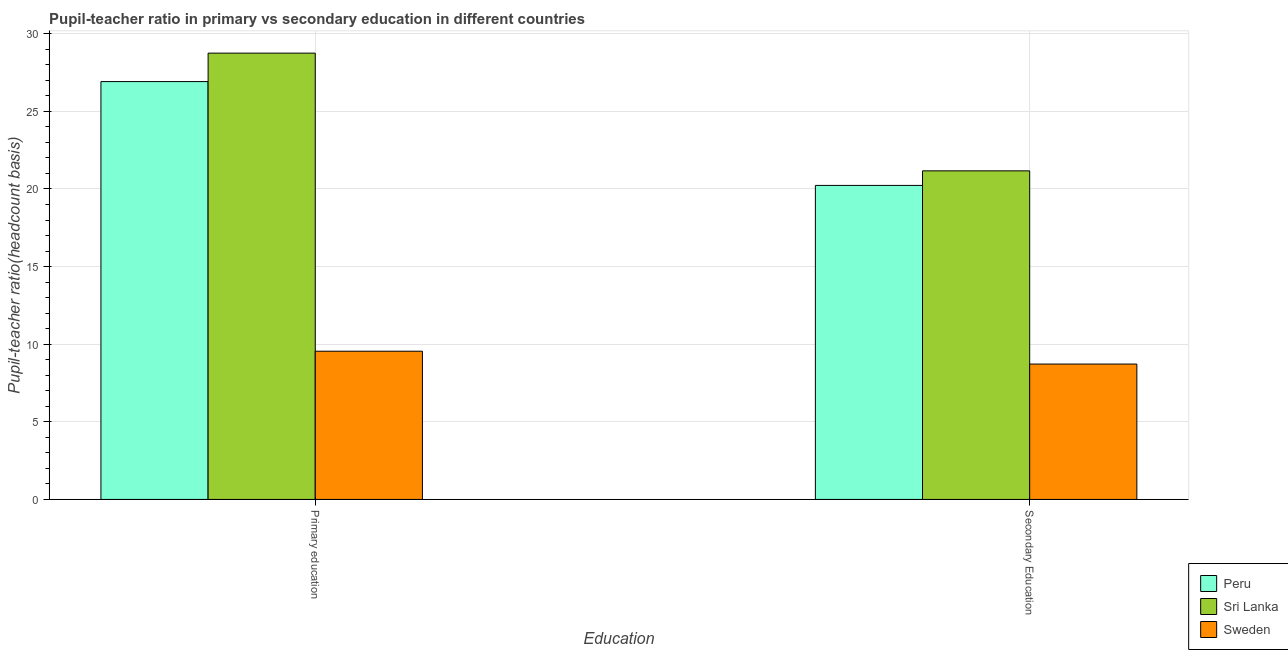How many different coloured bars are there?
Ensure brevity in your answer.  3. How many groups of bars are there?
Keep it short and to the point. 2. Are the number of bars on each tick of the X-axis equal?
Keep it short and to the point. Yes. How many bars are there on the 2nd tick from the left?
Ensure brevity in your answer.  3. How many bars are there on the 1st tick from the right?
Your response must be concise. 3. What is the label of the 1st group of bars from the left?
Make the answer very short. Primary education. What is the pupil teacher ratio on secondary education in Sweden?
Offer a terse response. 8.72. Across all countries, what is the maximum pupil teacher ratio on secondary education?
Your answer should be very brief. 21.17. Across all countries, what is the minimum pupil teacher ratio on secondary education?
Provide a short and direct response. 8.72. In which country was the pupil teacher ratio on secondary education maximum?
Give a very brief answer. Sri Lanka. What is the total pupil teacher ratio on secondary education in the graph?
Offer a terse response. 50.12. What is the difference between the pupil teacher ratio on secondary education in Peru and that in Sri Lanka?
Provide a short and direct response. -0.94. What is the difference between the pupil-teacher ratio in primary education in Sweden and the pupil teacher ratio on secondary education in Sri Lanka?
Provide a short and direct response. -11.62. What is the average pupil teacher ratio on secondary education per country?
Your answer should be compact. 16.71. What is the difference between the pupil-teacher ratio in primary education and pupil teacher ratio on secondary education in Sri Lanka?
Offer a very short reply. 7.58. In how many countries, is the pupil teacher ratio on secondary education greater than 21 ?
Offer a terse response. 1. What is the ratio of the pupil teacher ratio on secondary education in Sweden to that in Sri Lanka?
Give a very brief answer. 0.41. Is the pupil teacher ratio on secondary education in Sri Lanka less than that in Peru?
Your response must be concise. No. In how many countries, is the pupil-teacher ratio in primary education greater than the average pupil-teacher ratio in primary education taken over all countries?
Provide a short and direct response. 2. What does the 2nd bar from the left in Secondary Education represents?
Keep it short and to the point. Sri Lanka. What does the 2nd bar from the right in Secondary Education represents?
Offer a very short reply. Sri Lanka. How many bars are there?
Offer a very short reply. 6. Does the graph contain grids?
Provide a short and direct response. Yes. What is the title of the graph?
Keep it short and to the point. Pupil-teacher ratio in primary vs secondary education in different countries. Does "Malta" appear as one of the legend labels in the graph?
Make the answer very short. No. What is the label or title of the X-axis?
Offer a very short reply. Education. What is the label or title of the Y-axis?
Provide a succinct answer. Pupil-teacher ratio(headcount basis). What is the Pupil-teacher ratio(headcount basis) in Peru in Primary education?
Your answer should be compact. 26.92. What is the Pupil-teacher ratio(headcount basis) of Sri Lanka in Primary education?
Make the answer very short. 28.75. What is the Pupil-teacher ratio(headcount basis) of Sweden in Primary education?
Provide a succinct answer. 9.55. What is the Pupil-teacher ratio(headcount basis) of Peru in Secondary Education?
Give a very brief answer. 20.23. What is the Pupil-teacher ratio(headcount basis) in Sri Lanka in Secondary Education?
Make the answer very short. 21.17. What is the Pupil-teacher ratio(headcount basis) of Sweden in Secondary Education?
Give a very brief answer. 8.72. Across all Education, what is the maximum Pupil-teacher ratio(headcount basis) in Peru?
Your answer should be very brief. 26.92. Across all Education, what is the maximum Pupil-teacher ratio(headcount basis) in Sri Lanka?
Offer a terse response. 28.75. Across all Education, what is the maximum Pupil-teacher ratio(headcount basis) of Sweden?
Provide a short and direct response. 9.55. Across all Education, what is the minimum Pupil-teacher ratio(headcount basis) in Peru?
Your answer should be very brief. 20.23. Across all Education, what is the minimum Pupil-teacher ratio(headcount basis) of Sri Lanka?
Ensure brevity in your answer.  21.17. Across all Education, what is the minimum Pupil-teacher ratio(headcount basis) in Sweden?
Make the answer very short. 8.72. What is the total Pupil-teacher ratio(headcount basis) of Peru in the graph?
Provide a succinct answer. 47.14. What is the total Pupil-teacher ratio(headcount basis) of Sri Lanka in the graph?
Provide a short and direct response. 49.92. What is the total Pupil-teacher ratio(headcount basis) of Sweden in the graph?
Your answer should be very brief. 18.27. What is the difference between the Pupil-teacher ratio(headcount basis) in Peru in Primary education and that in Secondary Education?
Make the answer very short. 6.69. What is the difference between the Pupil-teacher ratio(headcount basis) in Sri Lanka in Primary education and that in Secondary Education?
Offer a very short reply. 7.58. What is the difference between the Pupil-teacher ratio(headcount basis) of Sweden in Primary education and that in Secondary Education?
Make the answer very short. 0.83. What is the difference between the Pupil-teacher ratio(headcount basis) in Peru in Primary education and the Pupil-teacher ratio(headcount basis) in Sri Lanka in Secondary Education?
Provide a short and direct response. 5.75. What is the difference between the Pupil-teacher ratio(headcount basis) in Peru in Primary education and the Pupil-teacher ratio(headcount basis) in Sweden in Secondary Education?
Offer a very short reply. 18.2. What is the difference between the Pupil-teacher ratio(headcount basis) of Sri Lanka in Primary education and the Pupil-teacher ratio(headcount basis) of Sweden in Secondary Education?
Offer a terse response. 20.03. What is the average Pupil-teacher ratio(headcount basis) in Peru per Education?
Provide a short and direct response. 23.57. What is the average Pupil-teacher ratio(headcount basis) of Sri Lanka per Education?
Make the answer very short. 24.96. What is the average Pupil-teacher ratio(headcount basis) of Sweden per Education?
Give a very brief answer. 9.13. What is the difference between the Pupil-teacher ratio(headcount basis) of Peru and Pupil-teacher ratio(headcount basis) of Sri Lanka in Primary education?
Your answer should be very brief. -1.83. What is the difference between the Pupil-teacher ratio(headcount basis) in Peru and Pupil-teacher ratio(headcount basis) in Sweden in Primary education?
Make the answer very short. 17.37. What is the difference between the Pupil-teacher ratio(headcount basis) of Sri Lanka and Pupil-teacher ratio(headcount basis) of Sweden in Primary education?
Offer a very short reply. 19.2. What is the difference between the Pupil-teacher ratio(headcount basis) in Peru and Pupil-teacher ratio(headcount basis) in Sri Lanka in Secondary Education?
Your answer should be compact. -0.94. What is the difference between the Pupil-teacher ratio(headcount basis) of Peru and Pupil-teacher ratio(headcount basis) of Sweden in Secondary Education?
Your answer should be very brief. 11.51. What is the difference between the Pupil-teacher ratio(headcount basis) in Sri Lanka and Pupil-teacher ratio(headcount basis) in Sweden in Secondary Education?
Offer a terse response. 12.45. What is the ratio of the Pupil-teacher ratio(headcount basis) of Peru in Primary education to that in Secondary Education?
Ensure brevity in your answer.  1.33. What is the ratio of the Pupil-teacher ratio(headcount basis) of Sri Lanka in Primary education to that in Secondary Education?
Ensure brevity in your answer.  1.36. What is the ratio of the Pupil-teacher ratio(headcount basis) of Sweden in Primary education to that in Secondary Education?
Provide a short and direct response. 1.09. What is the difference between the highest and the second highest Pupil-teacher ratio(headcount basis) of Peru?
Provide a succinct answer. 6.69. What is the difference between the highest and the second highest Pupil-teacher ratio(headcount basis) of Sri Lanka?
Offer a terse response. 7.58. What is the difference between the highest and the second highest Pupil-teacher ratio(headcount basis) in Sweden?
Your answer should be very brief. 0.83. What is the difference between the highest and the lowest Pupil-teacher ratio(headcount basis) of Peru?
Give a very brief answer. 6.69. What is the difference between the highest and the lowest Pupil-teacher ratio(headcount basis) of Sri Lanka?
Your answer should be compact. 7.58. What is the difference between the highest and the lowest Pupil-teacher ratio(headcount basis) of Sweden?
Your answer should be very brief. 0.83. 